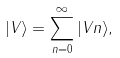Convert formula to latex. <formula><loc_0><loc_0><loc_500><loc_500>| V \rangle = \sum _ { n = 0 } ^ { \infty } | V n \rangle ,</formula> 